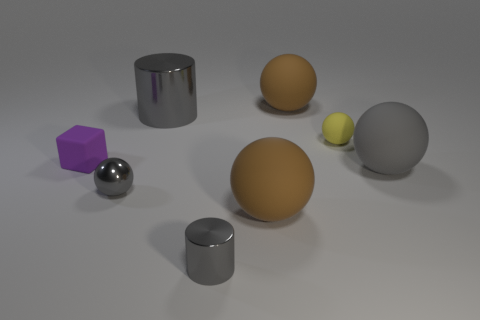There is a large ball that is the same color as the big metal cylinder; what is it made of?
Your answer should be compact. Rubber. What number of things are shiny cubes or large rubber things behind the cube?
Your answer should be compact. 1. What is the purple cube made of?
Offer a terse response. Rubber. There is a tiny gray object that is the same shape as the large gray rubber object; what material is it?
Keep it short and to the point. Metal. What is the color of the rubber thing that is left of the small sphere that is to the left of the big cylinder?
Give a very brief answer. Purple. What number of rubber objects are large red balls or large brown things?
Offer a terse response. 2. Is the material of the big gray cylinder the same as the tiny gray cylinder?
Your answer should be compact. Yes. There is a tiny ball left of the large brown matte object behind the yellow rubber ball; what is its material?
Provide a short and direct response. Metal. What number of small things are either green shiny objects or metallic balls?
Provide a short and direct response. 1. The yellow ball has what size?
Ensure brevity in your answer.  Small. 